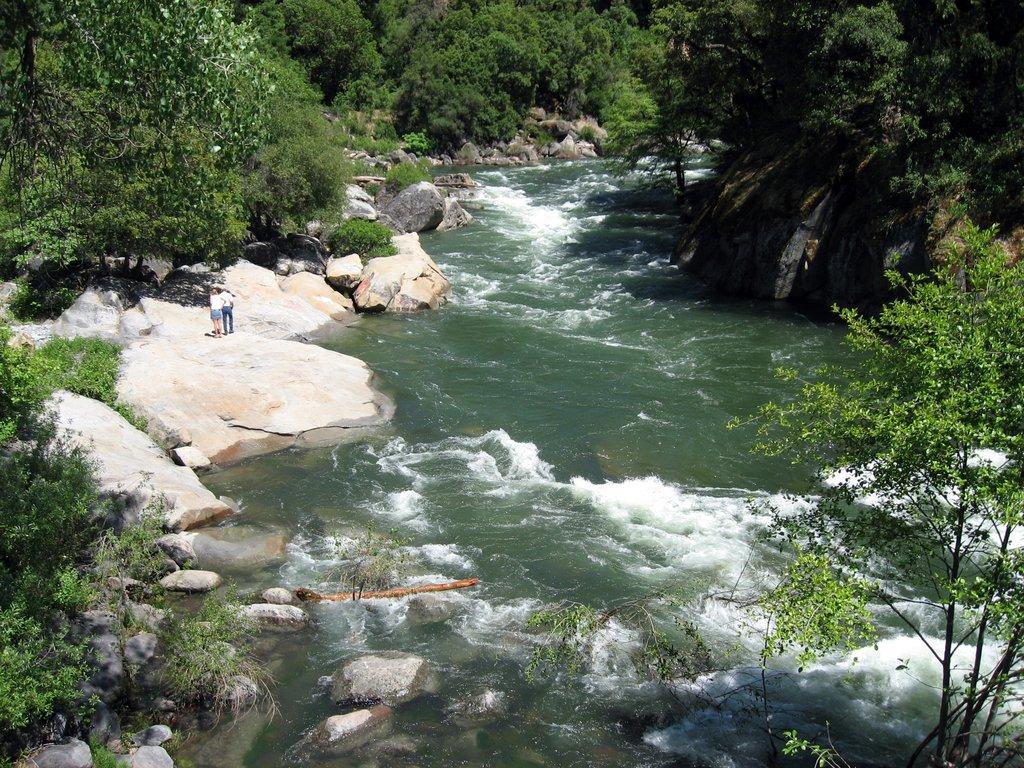In one or two sentences, can you explain what this image depicts? In this picture there is flowing water at the center of the image, and there are trees all around the area of the image and there are rocks at the left and right side of the image, it seems to be the view of valley. 